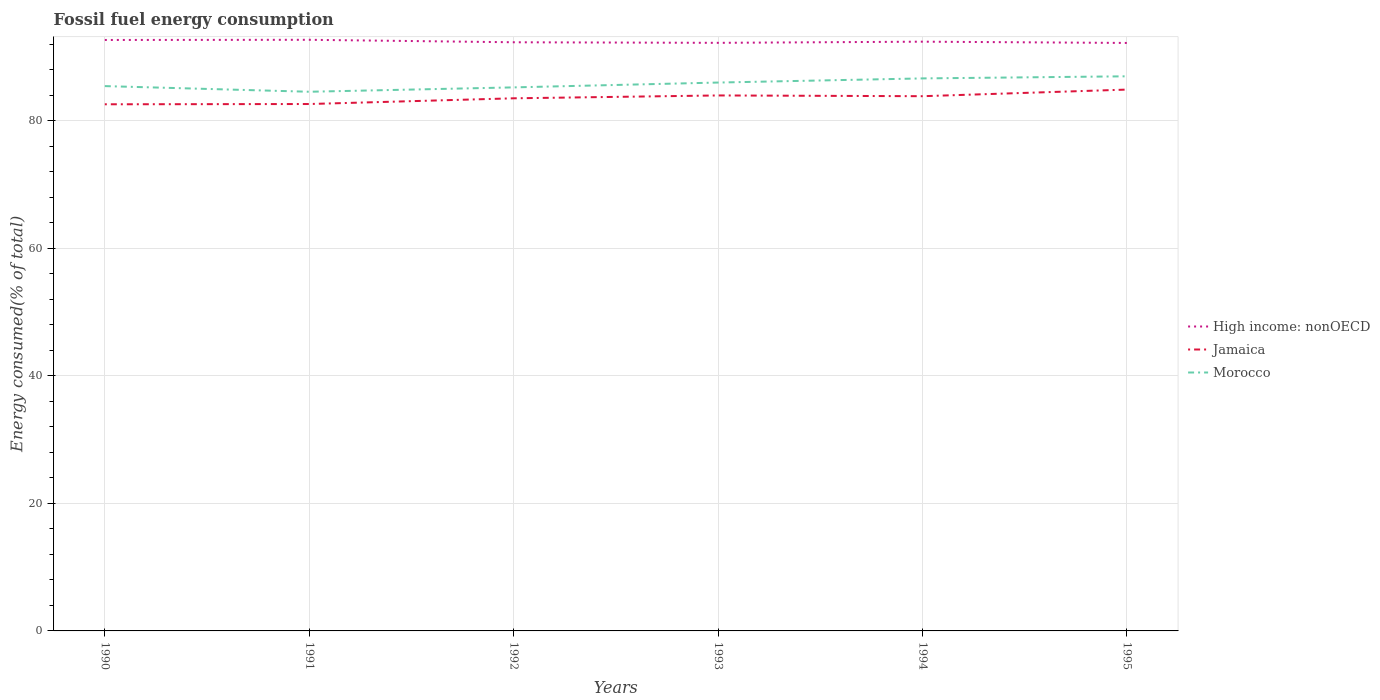How many different coloured lines are there?
Provide a succinct answer. 3. Does the line corresponding to Morocco intersect with the line corresponding to High income: nonOECD?
Provide a short and direct response. No. Is the number of lines equal to the number of legend labels?
Make the answer very short. Yes. Across all years, what is the maximum percentage of energy consumed in Morocco?
Keep it short and to the point. 84.56. In which year was the percentage of energy consumed in Morocco maximum?
Ensure brevity in your answer.  1991. What is the total percentage of energy consumed in Morocco in the graph?
Give a very brief answer. 0.89. What is the difference between the highest and the second highest percentage of energy consumed in Morocco?
Ensure brevity in your answer.  2.42. Is the percentage of energy consumed in Morocco strictly greater than the percentage of energy consumed in High income: nonOECD over the years?
Offer a terse response. Yes. How many lines are there?
Keep it short and to the point. 3. Does the graph contain any zero values?
Provide a succinct answer. No. Does the graph contain grids?
Your answer should be very brief. Yes. Where does the legend appear in the graph?
Offer a terse response. Center right. How many legend labels are there?
Offer a terse response. 3. What is the title of the graph?
Provide a short and direct response. Fossil fuel energy consumption. Does "Lebanon" appear as one of the legend labels in the graph?
Offer a very short reply. No. What is the label or title of the Y-axis?
Provide a short and direct response. Energy consumed(% of total). What is the Energy consumed(% of total) of High income: nonOECD in 1990?
Offer a very short reply. 92.68. What is the Energy consumed(% of total) of Jamaica in 1990?
Keep it short and to the point. 82.6. What is the Energy consumed(% of total) of Morocco in 1990?
Your response must be concise. 85.45. What is the Energy consumed(% of total) in High income: nonOECD in 1991?
Give a very brief answer. 92.71. What is the Energy consumed(% of total) of Jamaica in 1991?
Your answer should be compact. 82.64. What is the Energy consumed(% of total) of Morocco in 1991?
Offer a terse response. 84.56. What is the Energy consumed(% of total) in High income: nonOECD in 1992?
Your answer should be compact. 92.32. What is the Energy consumed(% of total) in Jamaica in 1992?
Your answer should be compact. 83.54. What is the Energy consumed(% of total) of Morocco in 1992?
Provide a succinct answer. 85.25. What is the Energy consumed(% of total) of High income: nonOECD in 1993?
Your answer should be compact. 92.24. What is the Energy consumed(% of total) of Jamaica in 1993?
Provide a short and direct response. 83.98. What is the Energy consumed(% of total) of Morocco in 1993?
Offer a terse response. 86.01. What is the Energy consumed(% of total) in High income: nonOECD in 1994?
Give a very brief answer. 92.42. What is the Energy consumed(% of total) in Jamaica in 1994?
Offer a very short reply. 83.87. What is the Energy consumed(% of total) of Morocco in 1994?
Give a very brief answer. 86.66. What is the Energy consumed(% of total) of High income: nonOECD in 1995?
Your response must be concise. 92.22. What is the Energy consumed(% of total) of Jamaica in 1995?
Offer a terse response. 84.9. What is the Energy consumed(% of total) in Morocco in 1995?
Provide a short and direct response. 86.99. Across all years, what is the maximum Energy consumed(% of total) of High income: nonOECD?
Your response must be concise. 92.71. Across all years, what is the maximum Energy consumed(% of total) of Jamaica?
Offer a very short reply. 84.9. Across all years, what is the maximum Energy consumed(% of total) of Morocco?
Your answer should be compact. 86.99. Across all years, what is the minimum Energy consumed(% of total) in High income: nonOECD?
Your response must be concise. 92.22. Across all years, what is the minimum Energy consumed(% of total) in Jamaica?
Ensure brevity in your answer.  82.6. Across all years, what is the minimum Energy consumed(% of total) in Morocco?
Offer a very short reply. 84.56. What is the total Energy consumed(% of total) in High income: nonOECD in the graph?
Offer a very short reply. 554.59. What is the total Energy consumed(% of total) in Jamaica in the graph?
Ensure brevity in your answer.  501.52. What is the total Energy consumed(% of total) of Morocco in the graph?
Provide a succinct answer. 514.91. What is the difference between the Energy consumed(% of total) in High income: nonOECD in 1990 and that in 1991?
Your answer should be compact. -0.03. What is the difference between the Energy consumed(% of total) in Jamaica in 1990 and that in 1991?
Provide a succinct answer. -0.04. What is the difference between the Energy consumed(% of total) of Morocco in 1990 and that in 1991?
Your answer should be very brief. 0.89. What is the difference between the Energy consumed(% of total) in High income: nonOECD in 1990 and that in 1992?
Your response must be concise. 0.36. What is the difference between the Energy consumed(% of total) of Jamaica in 1990 and that in 1992?
Your answer should be very brief. -0.94. What is the difference between the Energy consumed(% of total) in Morocco in 1990 and that in 1992?
Offer a very short reply. 0.2. What is the difference between the Energy consumed(% of total) in High income: nonOECD in 1990 and that in 1993?
Give a very brief answer. 0.45. What is the difference between the Energy consumed(% of total) in Jamaica in 1990 and that in 1993?
Keep it short and to the point. -1.39. What is the difference between the Energy consumed(% of total) in Morocco in 1990 and that in 1993?
Ensure brevity in your answer.  -0.56. What is the difference between the Energy consumed(% of total) of High income: nonOECD in 1990 and that in 1994?
Offer a very short reply. 0.27. What is the difference between the Energy consumed(% of total) in Jamaica in 1990 and that in 1994?
Keep it short and to the point. -1.27. What is the difference between the Energy consumed(% of total) in Morocco in 1990 and that in 1994?
Make the answer very short. -1.21. What is the difference between the Energy consumed(% of total) of High income: nonOECD in 1990 and that in 1995?
Give a very brief answer. 0.47. What is the difference between the Energy consumed(% of total) in Jamaica in 1990 and that in 1995?
Keep it short and to the point. -2.31. What is the difference between the Energy consumed(% of total) in Morocco in 1990 and that in 1995?
Ensure brevity in your answer.  -1.54. What is the difference between the Energy consumed(% of total) in High income: nonOECD in 1991 and that in 1992?
Provide a succinct answer. 0.39. What is the difference between the Energy consumed(% of total) in Jamaica in 1991 and that in 1992?
Give a very brief answer. -0.9. What is the difference between the Energy consumed(% of total) of Morocco in 1991 and that in 1992?
Provide a succinct answer. -0.69. What is the difference between the Energy consumed(% of total) of High income: nonOECD in 1991 and that in 1993?
Offer a very short reply. 0.48. What is the difference between the Energy consumed(% of total) of Jamaica in 1991 and that in 1993?
Make the answer very short. -1.34. What is the difference between the Energy consumed(% of total) of Morocco in 1991 and that in 1993?
Provide a succinct answer. -1.44. What is the difference between the Energy consumed(% of total) of High income: nonOECD in 1991 and that in 1994?
Keep it short and to the point. 0.29. What is the difference between the Energy consumed(% of total) in Jamaica in 1991 and that in 1994?
Offer a very short reply. -1.23. What is the difference between the Energy consumed(% of total) of Morocco in 1991 and that in 1994?
Your answer should be compact. -2.09. What is the difference between the Energy consumed(% of total) in High income: nonOECD in 1991 and that in 1995?
Keep it short and to the point. 0.49. What is the difference between the Energy consumed(% of total) in Jamaica in 1991 and that in 1995?
Your answer should be very brief. -2.26. What is the difference between the Energy consumed(% of total) of Morocco in 1991 and that in 1995?
Your answer should be very brief. -2.42. What is the difference between the Energy consumed(% of total) of High income: nonOECD in 1992 and that in 1993?
Make the answer very short. 0.09. What is the difference between the Energy consumed(% of total) of Jamaica in 1992 and that in 1993?
Your answer should be very brief. -0.45. What is the difference between the Energy consumed(% of total) in Morocco in 1992 and that in 1993?
Ensure brevity in your answer.  -0.76. What is the difference between the Energy consumed(% of total) in High income: nonOECD in 1992 and that in 1994?
Offer a very short reply. -0.09. What is the difference between the Energy consumed(% of total) of Jamaica in 1992 and that in 1994?
Keep it short and to the point. -0.33. What is the difference between the Energy consumed(% of total) of Morocco in 1992 and that in 1994?
Offer a terse response. -1.41. What is the difference between the Energy consumed(% of total) in High income: nonOECD in 1992 and that in 1995?
Your answer should be compact. 0.11. What is the difference between the Energy consumed(% of total) of Jamaica in 1992 and that in 1995?
Make the answer very short. -1.37. What is the difference between the Energy consumed(% of total) in Morocco in 1992 and that in 1995?
Make the answer very short. -1.74. What is the difference between the Energy consumed(% of total) in High income: nonOECD in 1993 and that in 1994?
Make the answer very short. -0.18. What is the difference between the Energy consumed(% of total) in Jamaica in 1993 and that in 1994?
Give a very brief answer. 0.12. What is the difference between the Energy consumed(% of total) in Morocco in 1993 and that in 1994?
Your response must be concise. -0.65. What is the difference between the Energy consumed(% of total) of High income: nonOECD in 1993 and that in 1995?
Provide a succinct answer. 0.02. What is the difference between the Energy consumed(% of total) of Jamaica in 1993 and that in 1995?
Provide a short and direct response. -0.92. What is the difference between the Energy consumed(% of total) in Morocco in 1993 and that in 1995?
Ensure brevity in your answer.  -0.98. What is the difference between the Energy consumed(% of total) of High income: nonOECD in 1994 and that in 1995?
Make the answer very short. 0.2. What is the difference between the Energy consumed(% of total) of Jamaica in 1994 and that in 1995?
Ensure brevity in your answer.  -1.04. What is the difference between the Energy consumed(% of total) in Morocco in 1994 and that in 1995?
Keep it short and to the point. -0.33. What is the difference between the Energy consumed(% of total) of High income: nonOECD in 1990 and the Energy consumed(% of total) of Jamaica in 1991?
Provide a short and direct response. 10.05. What is the difference between the Energy consumed(% of total) of High income: nonOECD in 1990 and the Energy consumed(% of total) of Morocco in 1991?
Your response must be concise. 8.12. What is the difference between the Energy consumed(% of total) of Jamaica in 1990 and the Energy consumed(% of total) of Morocco in 1991?
Keep it short and to the point. -1.97. What is the difference between the Energy consumed(% of total) of High income: nonOECD in 1990 and the Energy consumed(% of total) of Jamaica in 1992?
Keep it short and to the point. 9.15. What is the difference between the Energy consumed(% of total) in High income: nonOECD in 1990 and the Energy consumed(% of total) in Morocco in 1992?
Make the answer very short. 7.44. What is the difference between the Energy consumed(% of total) of Jamaica in 1990 and the Energy consumed(% of total) of Morocco in 1992?
Your answer should be very brief. -2.65. What is the difference between the Energy consumed(% of total) of High income: nonOECD in 1990 and the Energy consumed(% of total) of Jamaica in 1993?
Provide a succinct answer. 8.7. What is the difference between the Energy consumed(% of total) in High income: nonOECD in 1990 and the Energy consumed(% of total) in Morocco in 1993?
Provide a short and direct response. 6.68. What is the difference between the Energy consumed(% of total) in Jamaica in 1990 and the Energy consumed(% of total) in Morocco in 1993?
Provide a short and direct response. -3.41. What is the difference between the Energy consumed(% of total) in High income: nonOECD in 1990 and the Energy consumed(% of total) in Jamaica in 1994?
Your response must be concise. 8.82. What is the difference between the Energy consumed(% of total) in High income: nonOECD in 1990 and the Energy consumed(% of total) in Morocco in 1994?
Provide a succinct answer. 6.03. What is the difference between the Energy consumed(% of total) of Jamaica in 1990 and the Energy consumed(% of total) of Morocco in 1994?
Provide a succinct answer. -4.06. What is the difference between the Energy consumed(% of total) in High income: nonOECD in 1990 and the Energy consumed(% of total) in Jamaica in 1995?
Ensure brevity in your answer.  7.78. What is the difference between the Energy consumed(% of total) of High income: nonOECD in 1990 and the Energy consumed(% of total) of Morocco in 1995?
Give a very brief answer. 5.7. What is the difference between the Energy consumed(% of total) in Jamaica in 1990 and the Energy consumed(% of total) in Morocco in 1995?
Provide a short and direct response. -4.39. What is the difference between the Energy consumed(% of total) in High income: nonOECD in 1991 and the Energy consumed(% of total) in Jamaica in 1992?
Your response must be concise. 9.18. What is the difference between the Energy consumed(% of total) in High income: nonOECD in 1991 and the Energy consumed(% of total) in Morocco in 1992?
Offer a terse response. 7.46. What is the difference between the Energy consumed(% of total) of Jamaica in 1991 and the Energy consumed(% of total) of Morocco in 1992?
Offer a terse response. -2.61. What is the difference between the Energy consumed(% of total) in High income: nonOECD in 1991 and the Energy consumed(% of total) in Jamaica in 1993?
Give a very brief answer. 8.73. What is the difference between the Energy consumed(% of total) of High income: nonOECD in 1991 and the Energy consumed(% of total) of Morocco in 1993?
Give a very brief answer. 6.7. What is the difference between the Energy consumed(% of total) of Jamaica in 1991 and the Energy consumed(% of total) of Morocco in 1993?
Give a very brief answer. -3.37. What is the difference between the Energy consumed(% of total) of High income: nonOECD in 1991 and the Energy consumed(% of total) of Jamaica in 1994?
Provide a short and direct response. 8.85. What is the difference between the Energy consumed(% of total) in High income: nonOECD in 1991 and the Energy consumed(% of total) in Morocco in 1994?
Your answer should be compact. 6.06. What is the difference between the Energy consumed(% of total) in Jamaica in 1991 and the Energy consumed(% of total) in Morocco in 1994?
Your answer should be compact. -4.02. What is the difference between the Energy consumed(% of total) of High income: nonOECD in 1991 and the Energy consumed(% of total) of Jamaica in 1995?
Offer a very short reply. 7.81. What is the difference between the Energy consumed(% of total) in High income: nonOECD in 1991 and the Energy consumed(% of total) in Morocco in 1995?
Your response must be concise. 5.72. What is the difference between the Energy consumed(% of total) in Jamaica in 1991 and the Energy consumed(% of total) in Morocco in 1995?
Your answer should be compact. -4.35. What is the difference between the Energy consumed(% of total) in High income: nonOECD in 1992 and the Energy consumed(% of total) in Jamaica in 1993?
Offer a very short reply. 8.34. What is the difference between the Energy consumed(% of total) in High income: nonOECD in 1992 and the Energy consumed(% of total) in Morocco in 1993?
Make the answer very short. 6.32. What is the difference between the Energy consumed(% of total) of Jamaica in 1992 and the Energy consumed(% of total) of Morocco in 1993?
Give a very brief answer. -2.47. What is the difference between the Energy consumed(% of total) in High income: nonOECD in 1992 and the Energy consumed(% of total) in Jamaica in 1994?
Provide a short and direct response. 8.46. What is the difference between the Energy consumed(% of total) of High income: nonOECD in 1992 and the Energy consumed(% of total) of Morocco in 1994?
Your answer should be compact. 5.67. What is the difference between the Energy consumed(% of total) of Jamaica in 1992 and the Energy consumed(% of total) of Morocco in 1994?
Make the answer very short. -3.12. What is the difference between the Energy consumed(% of total) in High income: nonOECD in 1992 and the Energy consumed(% of total) in Jamaica in 1995?
Ensure brevity in your answer.  7.42. What is the difference between the Energy consumed(% of total) of High income: nonOECD in 1992 and the Energy consumed(% of total) of Morocco in 1995?
Keep it short and to the point. 5.34. What is the difference between the Energy consumed(% of total) of Jamaica in 1992 and the Energy consumed(% of total) of Morocco in 1995?
Ensure brevity in your answer.  -3.45. What is the difference between the Energy consumed(% of total) of High income: nonOECD in 1993 and the Energy consumed(% of total) of Jamaica in 1994?
Give a very brief answer. 8.37. What is the difference between the Energy consumed(% of total) of High income: nonOECD in 1993 and the Energy consumed(% of total) of Morocco in 1994?
Your answer should be compact. 5.58. What is the difference between the Energy consumed(% of total) of Jamaica in 1993 and the Energy consumed(% of total) of Morocco in 1994?
Provide a short and direct response. -2.67. What is the difference between the Energy consumed(% of total) of High income: nonOECD in 1993 and the Energy consumed(% of total) of Jamaica in 1995?
Keep it short and to the point. 7.33. What is the difference between the Energy consumed(% of total) of High income: nonOECD in 1993 and the Energy consumed(% of total) of Morocco in 1995?
Provide a short and direct response. 5.25. What is the difference between the Energy consumed(% of total) of Jamaica in 1993 and the Energy consumed(% of total) of Morocco in 1995?
Make the answer very short. -3. What is the difference between the Energy consumed(% of total) of High income: nonOECD in 1994 and the Energy consumed(% of total) of Jamaica in 1995?
Offer a very short reply. 7.51. What is the difference between the Energy consumed(% of total) in High income: nonOECD in 1994 and the Energy consumed(% of total) in Morocco in 1995?
Make the answer very short. 5.43. What is the difference between the Energy consumed(% of total) of Jamaica in 1994 and the Energy consumed(% of total) of Morocco in 1995?
Your answer should be very brief. -3.12. What is the average Energy consumed(% of total) in High income: nonOECD per year?
Make the answer very short. 92.43. What is the average Energy consumed(% of total) in Jamaica per year?
Your answer should be compact. 83.59. What is the average Energy consumed(% of total) in Morocco per year?
Offer a very short reply. 85.82. In the year 1990, what is the difference between the Energy consumed(% of total) in High income: nonOECD and Energy consumed(% of total) in Jamaica?
Offer a very short reply. 10.09. In the year 1990, what is the difference between the Energy consumed(% of total) of High income: nonOECD and Energy consumed(% of total) of Morocco?
Provide a short and direct response. 7.23. In the year 1990, what is the difference between the Energy consumed(% of total) in Jamaica and Energy consumed(% of total) in Morocco?
Keep it short and to the point. -2.85. In the year 1991, what is the difference between the Energy consumed(% of total) of High income: nonOECD and Energy consumed(% of total) of Jamaica?
Offer a terse response. 10.07. In the year 1991, what is the difference between the Energy consumed(% of total) of High income: nonOECD and Energy consumed(% of total) of Morocco?
Provide a short and direct response. 8.15. In the year 1991, what is the difference between the Energy consumed(% of total) in Jamaica and Energy consumed(% of total) in Morocco?
Provide a short and direct response. -1.92. In the year 1992, what is the difference between the Energy consumed(% of total) of High income: nonOECD and Energy consumed(% of total) of Jamaica?
Your answer should be compact. 8.79. In the year 1992, what is the difference between the Energy consumed(% of total) in High income: nonOECD and Energy consumed(% of total) in Morocco?
Provide a short and direct response. 7.07. In the year 1992, what is the difference between the Energy consumed(% of total) in Jamaica and Energy consumed(% of total) in Morocco?
Offer a very short reply. -1.71. In the year 1993, what is the difference between the Energy consumed(% of total) of High income: nonOECD and Energy consumed(% of total) of Jamaica?
Give a very brief answer. 8.25. In the year 1993, what is the difference between the Energy consumed(% of total) in High income: nonOECD and Energy consumed(% of total) in Morocco?
Provide a short and direct response. 6.23. In the year 1993, what is the difference between the Energy consumed(% of total) of Jamaica and Energy consumed(% of total) of Morocco?
Your answer should be compact. -2.02. In the year 1994, what is the difference between the Energy consumed(% of total) in High income: nonOECD and Energy consumed(% of total) in Jamaica?
Ensure brevity in your answer.  8.55. In the year 1994, what is the difference between the Energy consumed(% of total) in High income: nonOECD and Energy consumed(% of total) in Morocco?
Offer a very short reply. 5.76. In the year 1994, what is the difference between the Energy consumed(% of total) of Jamaica and Energy consumed(% of total) of Morocco?
Give a very brief answer. -2.79. In the year 1995, what is the difference between the Energy consumed(% of total) in High income: nonOECD and Energy consumed(% of total) in Jamaica?
Your answer should be compact. 7.31. In the year 1995, what is the difference between the Energy consumed(% of total) of High income: nonOECD and Energy consumed(% of total) of Morocco?
Keep it short and to the point. 5.23. In the year 1995, what is the difference between the Energy consumed(% of total) of Jamaica and Energy consumed(% of total) of Morocco?
Your answer should be very brief. -2.08. What is the ratio of the Energy consumed(% of total) of High income: nonOECD in 1990 to that in 1991?
Your response must be concise. 1. What is the ratio of the Energy consumed(% of total) in Jamaica in 1990 to that in 1991?
Offer a very short reply. 1. What is the ratio of the Energy consumed(% of total) in Morocco in 1990 to that in 1991?
Your answer should be compact. 1.01. What is the ratio of the Energy consumed(% of total) of High income: nonOECD in 1990 to that in 1992?
Offer a terse response. 1. What is the ratio of the Energy consumed(% of total) of Morocco in 1990 to that in 1992?
Offer a very short reply. 1. What is the ratio of the Energy consumed(% of total) in High income: nonOECD in 1990 to that in 1993?
Offer a terse response. 1. What is the ratio of the Energy consumed(% of total) of Jamaica in 1990 to that in 1993?
Ensure brevity in your answer.  0.98. What is the ratio of the Energy consumed(% of total) in Morocco in 1990 to that in 1993?
Keep it short and to the point. 0.99. What is the ratio of the Energy consumed(% of total) in Jamaica in 1990 to that in 1994?
Your answer should be compact. 0.98. What is the ratio of the Energy consumed(% of total) in Morocco in 1990 to that in 1994?
Provide a short and direct response. 0.99. What is the ratio of the Energy consumed(% of total) of High income: nonOECD in 1990 to that in 1995?
Offer a very short reply. 1.01. What is the ratio of the Energy consumed(% of total) in Jamaica in 1990 to that in 1995?
Provide a succinct answer. 0.97. What is the ratio of the Energy consumed(% of total) of Morocco in 1990 to that in 1995?
Your response must be concise. 0.98. What is the ratio of the Energy consumed(% of total) in Jamaica in 1991 to that in 1992?
Provide a short and direct response. 0.99. What is the ratio of the Energy consumed(% of total) of Morocco in 1991 to that in 1993?
Give a very brief answer. 0.98. What is the ratio of the Energy consumed(% of total) in Jamaica in 1991 to that in 1994?
Offer a terse response. 0.99. What is the ratio of the Energy consumed(% of total) of Morocco in 1991 to that in 1994?
Your answer should be compact. 0.98. What is the ratio of the Energy consumed(% of total) in High income: nonOECD in 1991 to that in 1995?
Offer a terse response. 1.01. What is the ratio of the Energy consumed(% of total) of Jamaica in 1991 to that in 1995?
Make the answer very short. 0.97. What is the ratio of the Energy consumed(% of total) in Morocco in 1991 to that in 1995?
Your answer should be compact. 0.97. What is the ratio of the Energy consumed(% of total) in Jamaica in 1992 to that in 1993?
Keep it short and to the point. 0.99. What is the ratio of the Energy consumed(% of total) in Morocco in 1992 to that in 1994?
Offer a very short reply. 0.98. What is the ratio of the Energy consumed(% of total) of High income: nonOECD in 1992 to that in 1995?
Provide a short and direct response. 1. What is the ratio of the Energy consumed(% of total) of Jamaica in 1992 to that in 1995?
Offer a very short reply. 0.98. What is the ratio of the Energy consumed(% of total) in Morocco in 1992 to that in 1995?
Keep it short and to the point. 0.98. What is the ratio of the Energy consumed(% of total) in High income: nonOECD in 1993 to that in 1994?
Offer a very short reply. 1. What is the ratio of the Energy consumed(% of total) in Morocco in 1993 to that in 1995?
Your answer should be very brief. 0.99. What is the ratio of the Energy consumed(% of total) in Morocco in 1994 to that in 1995?
Provide a succinct answer. 1. What is the difference between the highest and the second highest Energy consumed(% of total) of High income: nonOECD?
Offer a terse response. 0.03. What is the difference between the highest and the second highest Energy consumed(% of total) of Jamaica?
Make the answer very short. 0.92. What is the difference between the highest and the second highest Energy consumed(% of total) in Morocco?
Offer a terse response. 0.33. What is the difference between the highest and the lowest Energy consumed(% of total) in High income: nonOECD?
Ensure brevity in your answer.  0.49. What is the difference between the highest and the lowest Energy consumed(% of total) in Jamaica?
Your answer should be very brief. 2.31. What is the difference between the highest and the lowest Energy consumed(% of total) of Morocco?
Keep it short and to the point. 2.42. 